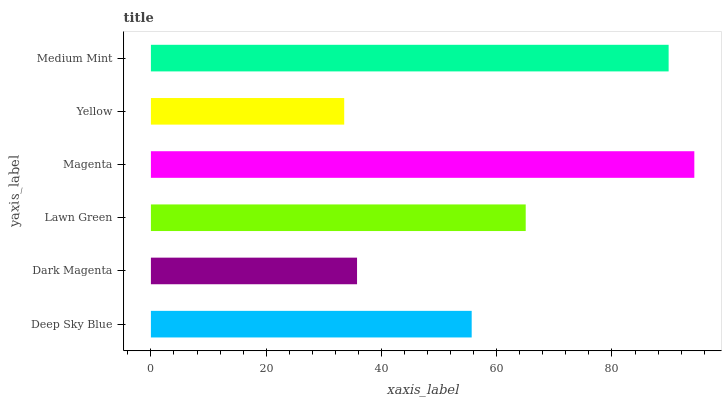Is Yellow the minimum?
Answer yes or no. Yes. Is Magenta the maximum?
Answer yes or no. Yes. Is Dark Magenta the minimum?
Answer yes or no. No. Is Dark Magenta the maximum?
Answer yes or no. No. Is Deep Sky Blue greater than Dark Magenta?
Answer yes or no. Yes. Is Dark Magenta less than Deep Sky Blue?
Answer yes or no. Yes. Is Dark Magenta greater than Deep Sky Blue?
Answer yes or no. No. Is Deep Sky Blue less than Dark Magenta?
Answer yes or no. No. Is Lawn Green the high median?
Answer yes or no. Yes. Is Deep Sky Blue the low median?
Answer yes or no. Yes. Is Dark Magenta the high median?
Answer yes or no. No. Is Yellow the low median?
Answer yes or no. No. 